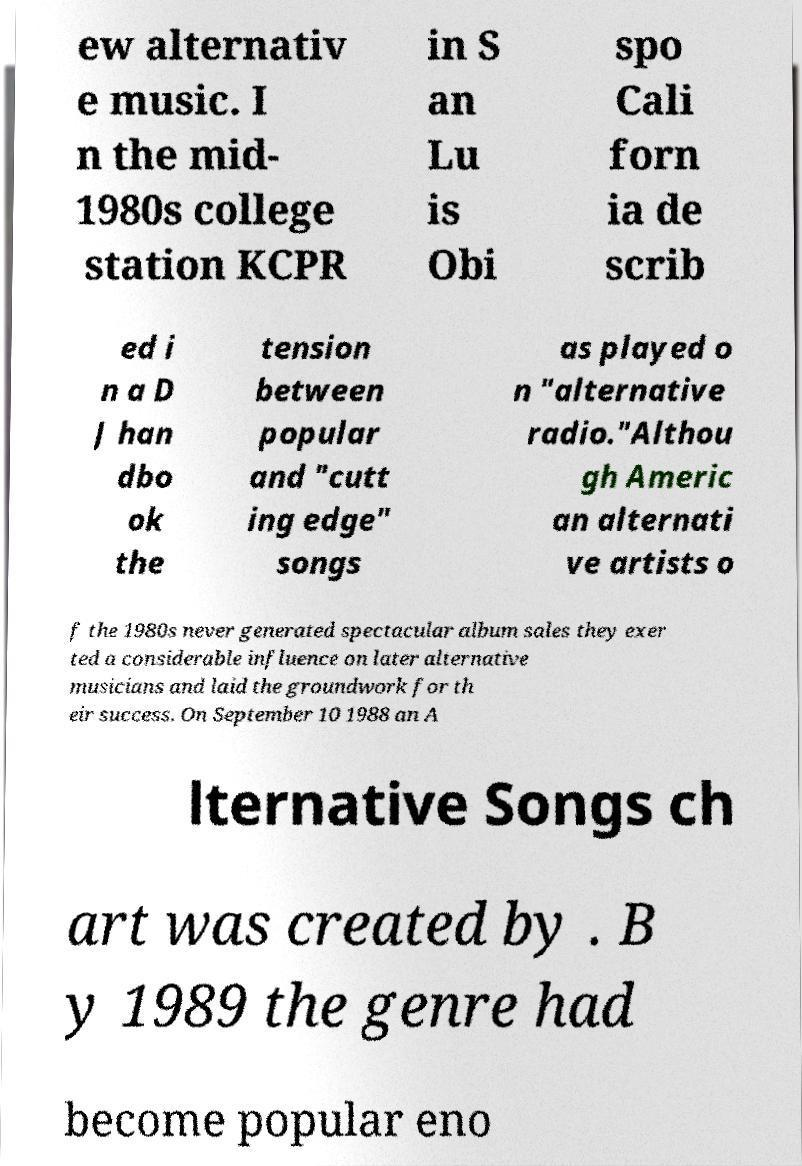Please read and relay the text visible in this image. What does it say? ew alternativ e music. I n the mid- 1980s college station KCPR in S an Lu is Obi spo Cali forn ia de scrib ed i n a D J han dbo ok the tension between popular and "cutt ing edge" songs as played o n "alternative radio."Althou gh Americ an alternati ve artists o f the 1980s never generated spectacular album sales they exer ted a considerable influence on later alternative musicians and laid the groundwork for th eir success. On September 10 1988 an A lternative Songs ch art was created by . B y 1989 the genre had become popular eno 